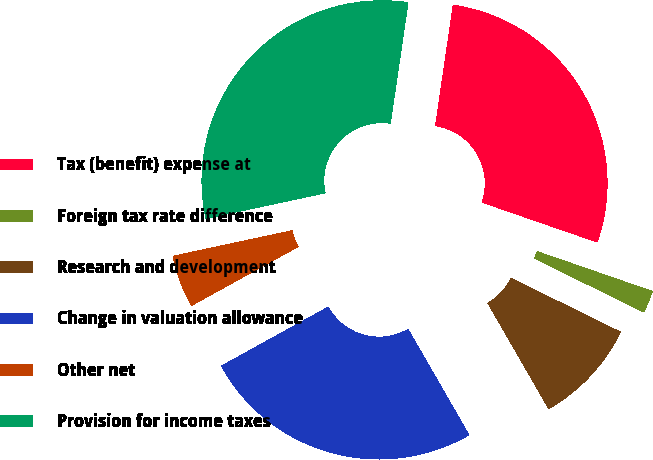Convert chart to OTSL. <chart><loc_0><loc_0><loc_500><loc_500><pie_chart><fcel>Tax (benefit) expense at<fcel>Foreign tax rate difference<fcel>Research and development<fcel>Change in valuation allowance<fcel>Other net<fcel>Provision for income taxes<nl><fcel>27.98%<fcel>1.97%<fcel>9.41%<fcel>25.29%<fcel>4.67%<fcel>30.68%<nl></chart> 